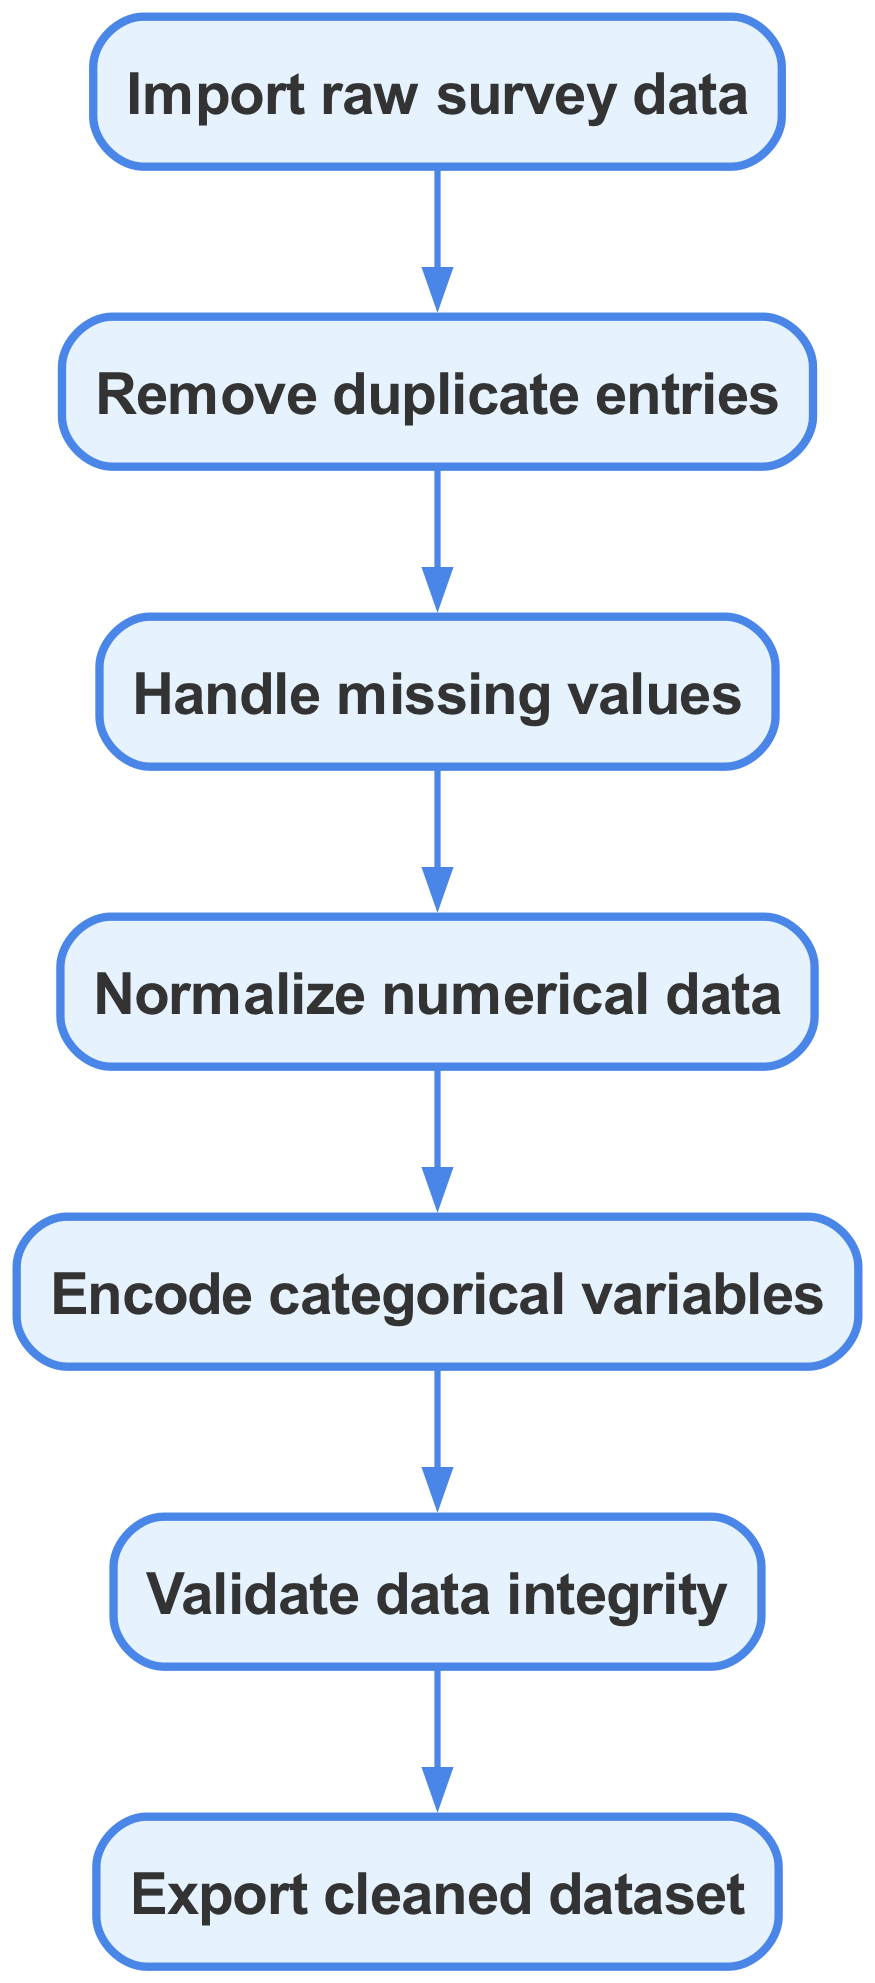What is the first step in the data preprocessing workflow? The first step in the workflow is represented by the first node in the diagram, which states "Import raw survey data."
Answer: Import raw survey data How many nodes are present in the diagram? By counting the nodes listed in the data, we find there are 7 nodes, each representing a distinct step in the data preprocessing flow.
Answer: 7 What action follows 'Handle missing values'? Following 'Handle missing values,' the next node in the sequence represents 'Normalize numerical data,' indicating what step comes next in the process.
Answer: Normalize numerical data Which nodes are directly connected to the 'Validate data integrity' node? The direct connection to the 'Validate data integrity' node comes from the preceding node 'Encode categorical variables,' confirming its position and the flow of actions leading to validation.
Answer: Encode categorical variables What is the last step of the preprocessing? The last step in the diagram is 'Export cleaned dataset,' which signifies that all prior actions lead to the final output of the preprocessing workflow.
Answer: Export cleaned dataset Which step includes the removal of duplicate entries? The step where duplicate entries are removed is clearly marked as 'Remove duplicate entries,' which occurs right after the importation of raw survey data.
Answer: Remove duplicate entries How many edges are in the diagram? Counting the edges in the diagram reveals there are 6 edges, which represent the directed connections between the nodes in the data preprocessing sequence.
Answer: 6 What is the purpose of 'Encode categorical variables'? 'Encode categorical variables' serves to convert categorical data into a numerical format, making it suitable for statistical analysis and modeling, and it logically follows normalization.
Answer: Convert categorical data to numerical format What indicates the flow from 'Normalize numerical data' to 'Encode categorical variables'? The directional edge from 'Normalize numerical data' to 'Encode categorical variables' indicates that these steps occur sequentially in the data preprocessing process, aligning one step after the other.
Answer: Directional edge 